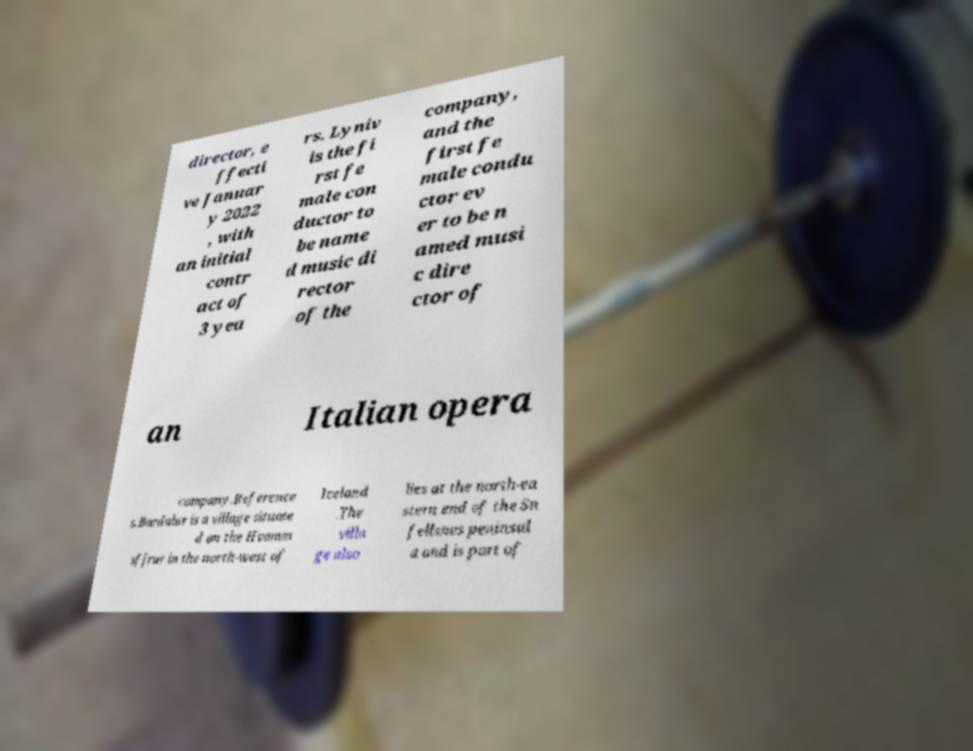Can you accurately transcribe the text from the provided image for me? director, e ffecti ve Januar y 2022 , with an initial contr act of 3 yea rs. Lyniv is the fi rst fe male con ductor to be name d music di rector of the company, and the first fe male condu ctor ev er to be n amed musi c dire ctor of an Italian opera company.Reference s.Bardalur is a village situate d on the Hvamm sfjrur in the north-west of Iceland .The villa ge also lies at the north-ea stern end of the Sn fellsnes peninsul a and is part of 